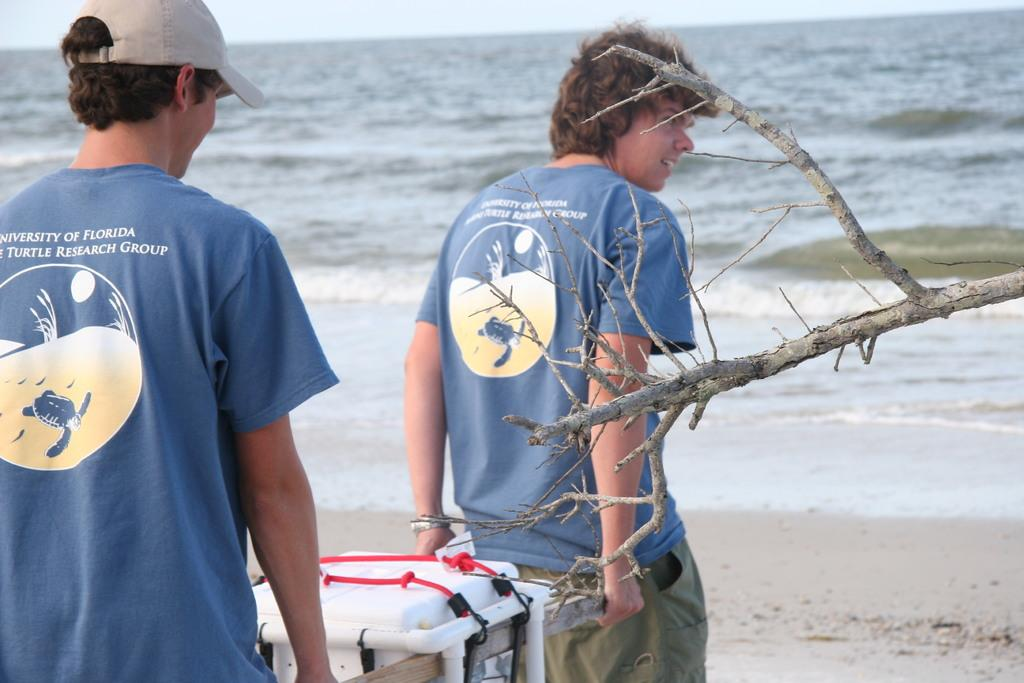How many people are in the image? There are two boys in the image. Where are the boys located in the image? The boys are on the left side of the image. What are the boys holding in the image? The boys are holding a box. What can be seen at the top side of the image? There is water visible at the top side of the image. What type of stamp can be seen on the box the boys are holding? There is no stamp visible on the box the boys are holding in the image. 